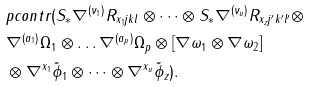Convert formula to latex. <formula><loc_0><loc_0><loc_500><loc_500>& p c o n t r ( S _ { * } \nabla ^ { ( \nu _ { 1 } ) } R _ { x _ { 1 } j k l } \otimes \dots \otimes S _ { * } \nabla ^ { ( \nu _ { u } ) } R _ { x _ { z } j ^ { \prime } k ^ { \prime } l ^ { \prime } } \otimes \\ & \nabla ^ { ( a _ { 1 } ) } \Omega _ { 1 } \otimes \dots \nabla ^ { ( a _ { p } ) } \Omega _ { p } \otimes [ \nabla \omega _ { 1 } \otimes \nabla \omega _ { 2 } ] \\ & \otimes \nabla ^ { x _ { 1 } } \tilde { \phi } _ { 1 } \otimes \dots \otimes \nabla ^ { x _ { u } } \tilde { \phi } _ { z } ) .</formula> 